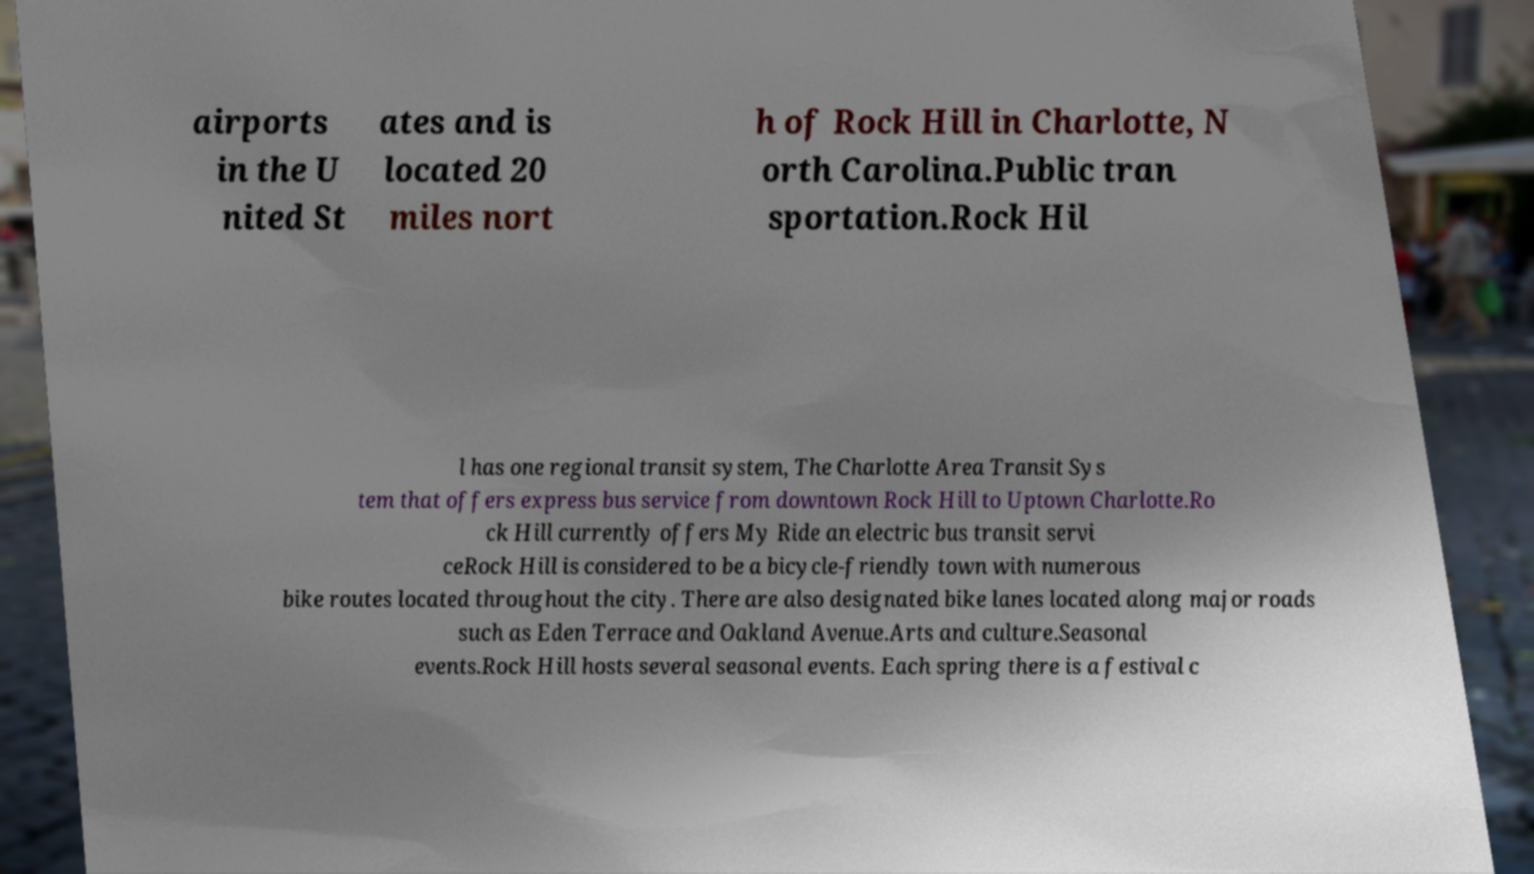For documentation purposes, I need the text within this image transcribed. Could you provide that? airports in the U nited St ates and is located 20 miles nort h of Rock Hill in Charlotte, N orth Carolina.Public tran sportation.Rock Hil l has one regional transit system, The Charlotte Area Transit Sys tem that offers express bus service from downtown Rock Hill to Uptown Charlotte.Ro ck Hill currently offers My Ride an electric bus transit servi ceRock Hill is considered to be a bicycle-friendly town with numerous bike routes located throughout the city. There are also designated bike lanes located along major roads such as Eden Terrace and Oakland Avenue.Arts and culture.Seasonal events.Rock Hill hosts several seasonal events. Each spring there is a festival c 